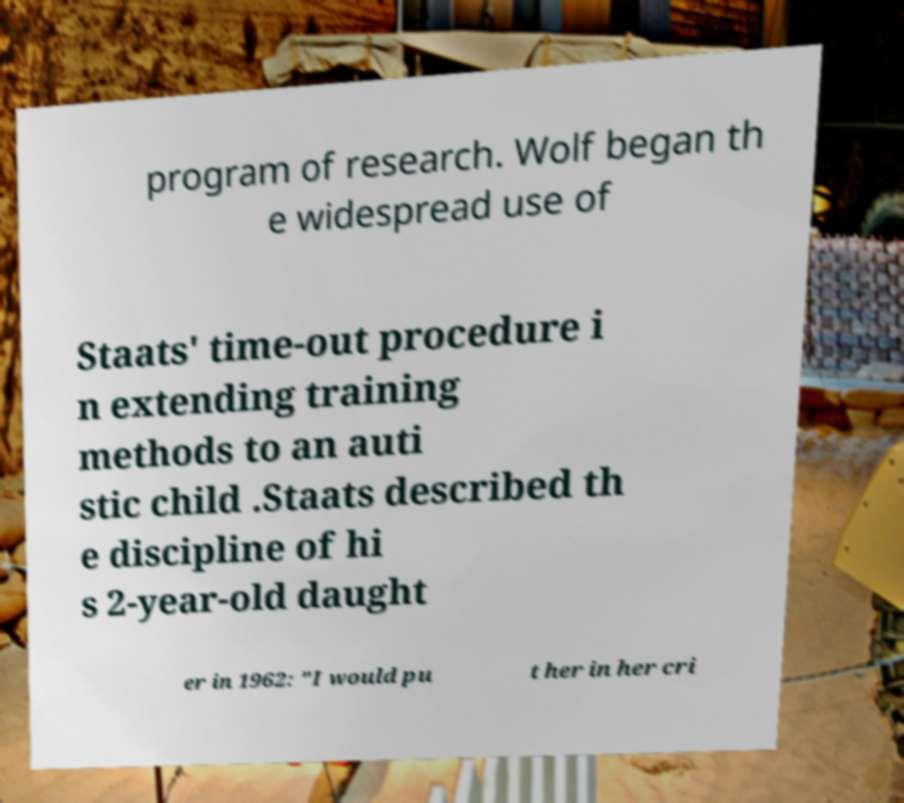Could you assist in decoding the text presented in this image and type it out clearly? program of research. Wolf began th e widespread use of Staats' time-out procedure i n extending training methods to an auti stic child .Staats described th e discipline of hi s 2-year-old daught er in 1962: "I would pu t her in her cri 